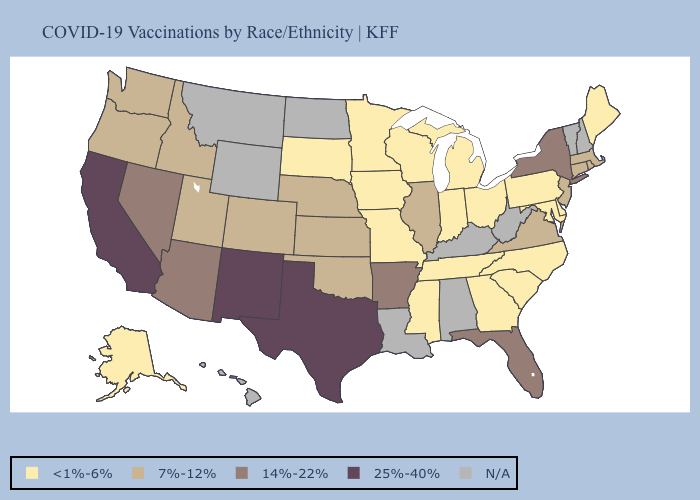Does Kansas have the highest value in the MidWest?
Give a very brief answer. Yes. What is the lowest value in the USA?
Keep it brief. <1%-6%. What is the value of Louisiana?
Concise answer only. N/A. Name the states that have a value in the range <1%-6%?
Give a very brief answer. Alaska, Delaware, Georgia, Indiana, Iowa, Maine, Maryland, Michigan, Minnesota, Mississippi, Missouri, North Carolina, Ohio, Pennsylvania, South Carolina, South Dakota, Tennessee, Wisconsin. How many symbols are there in the legend?
Answer briefly. 5. Is the legend a continuous bar?
Answer briefly. No. Does the first symbol in the legend represent the smallest category?
Be succinct. Yes. Name the states that have a value in the range N/A?
Quick response, please. Alabama, Hawaii, Kentucky, Louisiana, Montana, New Hampshire, North Dakota, Vermont, West Virginia, Wyoming. What is the value of Alaska?
Quick response, please. <1%-6%. Does Alaska have the lowest value in the West?
Write a very short answer. Yes. What is the highest value in the USA?
Keep it brief. 25%-40%. Which states hav the highest value in the Northeast?
Short answer required. New York. Name the states that have a value in the range 7%-12%?
Give a very brief answer. Colorado, Connecticut, Idaho, Illinois, Kansas, Massachusetts, Nebraska, New Jersey, Oklahoma, Oregon, Rhode Island, Utah, Virginia, Washington. 